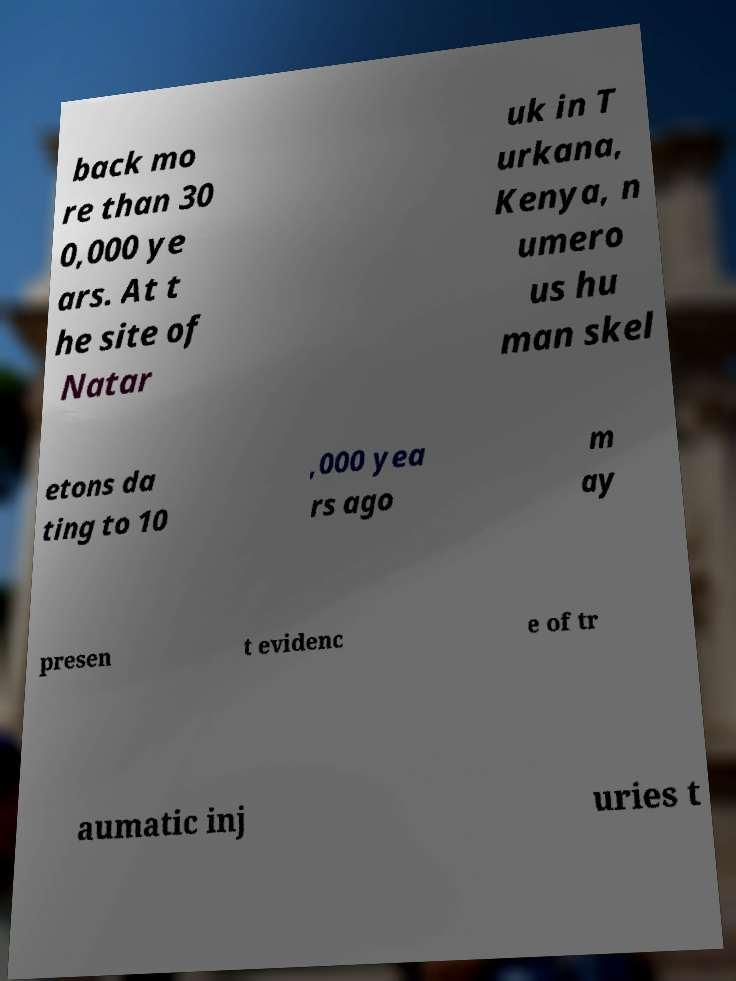Can you read and provide the text displayed in the image?This photo seems to have some interesting text. Can you extract and type it out for me? back mo re than 30 0,000 ye ars. At t he site of Natar uk in T urkana, Kenya, n umero us hu man skel etons da ting to 10 ,000 yea rs ago m ay presen t evidenc e of tr aumatic inj uries t 